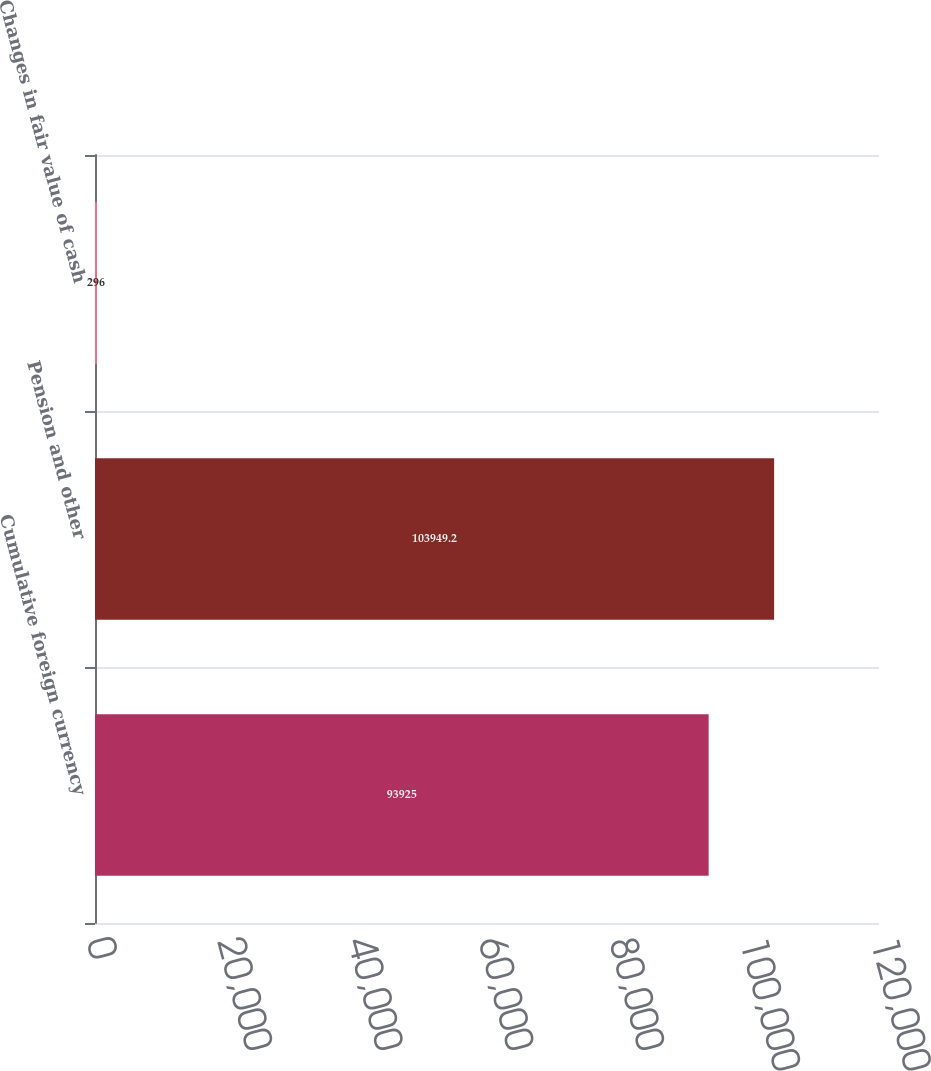Convert chart to OTSL. <chart><loc_0><loc_0><loc_500><loc_500><bar_chart><fcel>Cumulative foreign currency<fcel>Pension and other<fcel>Changes in fair value of cash<nl><fcel>93925<fcel>103949<fcel>296<nl></chart> 